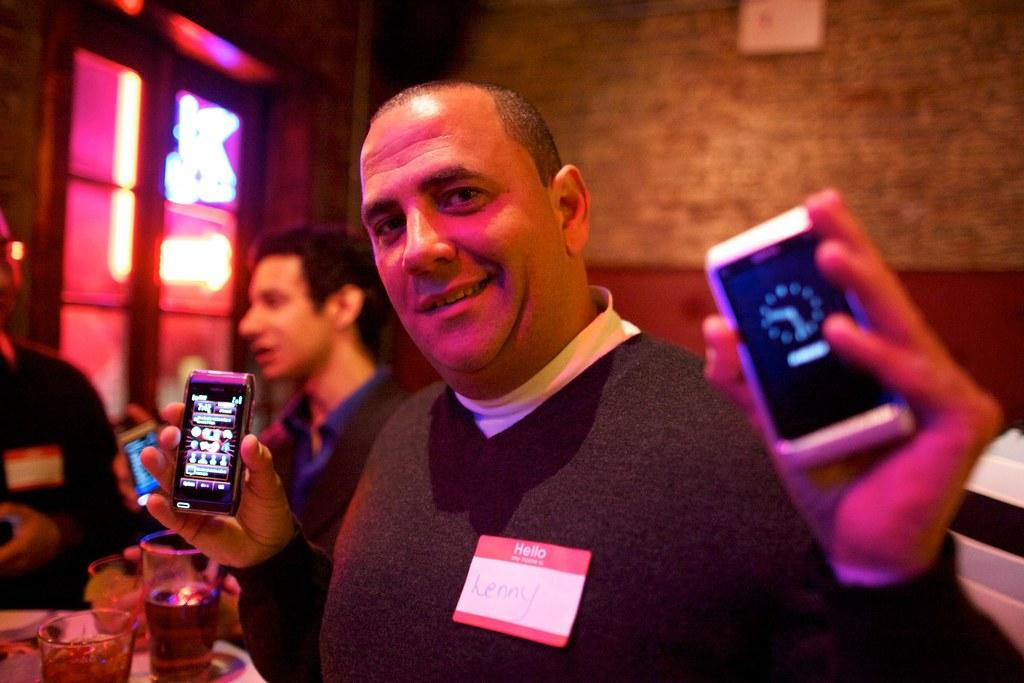<image>
Share a concise interpretation of the image provided. Lenny is currently at a convention and is showcasing brand new smartphones 